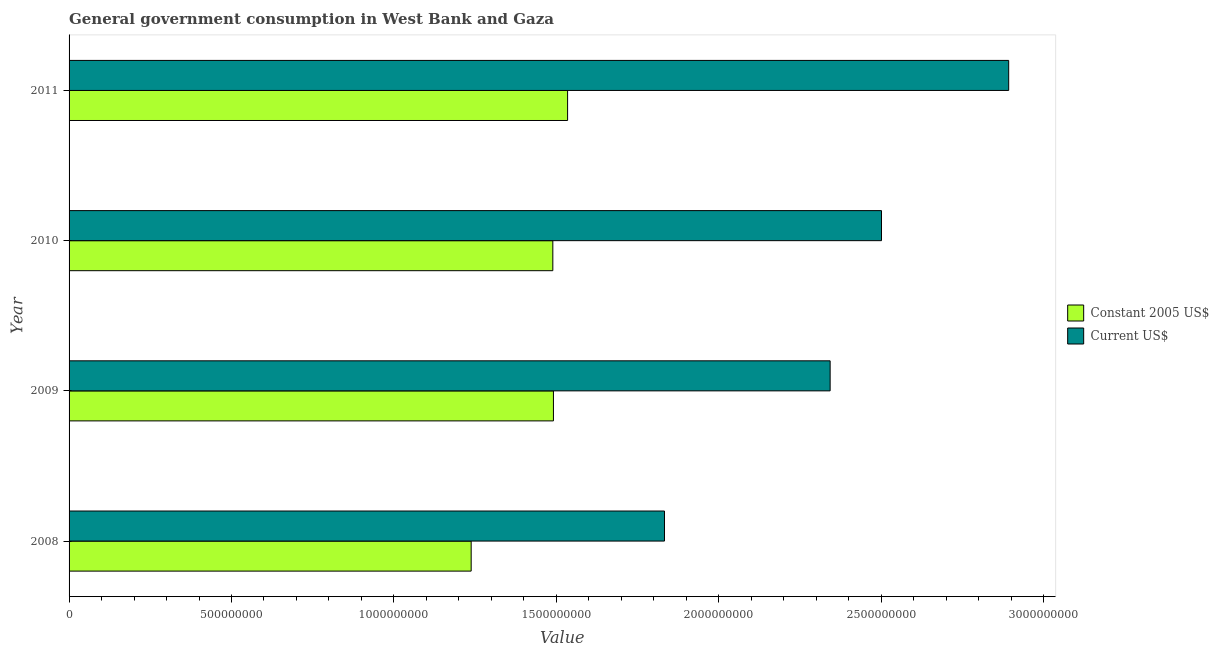How many different coloured bars are there?
Make the answer very short. 2. Are the number of bars per tick equal to the number of legend labels?
Provide a short and direct response. Yes. How many bars are there on the 2nd tick from the top?
Your answer should be compact. 2. How many bars are there on the 4th tick from the bottom?
Provide a short and direct response. 2. What is the label of the 2nd group of bars from the top?
Ensure brevity in your answer.  2010. In how many cases, is the number of bars for a given year not equal to the number of legend labels?
Provide a succinct answer. 0. What is the value consumed in constant 2005 us$ in 2009?
Ensure brevity in your answer.  1.49e+09. Across all years, what is the maximum value consumed in current us$?
Provide a short and direct response. 2.89e+09. Across all years, what is the minimum value consumed in constant 2005 us$?
Provide a succinct answer. 1.24e+09. In which year was the value consumed in constant 2005 us$ maximum?
Give a very brief answer. 2011. In which year was the value consumed in current us$ minimum?
Provide a short and direct response. 2008. What is the total value consumed in constant 2005 us$ in the graph?
Ensure brevity in your answer.  5.75e+09. What is the difference between the value consumed in constant 2005 us$ in 2009 and that in 2011?
Offer a terse response. -4.36e+07. What is the difference between the value consumed in current us$ in 2011 and the value consumed in constant 2005 us$ in 2010?
Your response must be concise. 1.40e+09. What is the average value consumed in current us$ per year?
Ensure brevity in your answer.  2.39e+09. In the year 2008, what is the difference between the value consumed in constant 2005 us$ and value consumed in current us$?
Offer a very short reply. -5.95e+08. In how many years, is the value consumed in constant 2005 us$ greater than 400000000 ?
Offer a terse response. 4. What is the ratio of the value consumed in current us$ in 2009 to that in 2010?
Provide a succinct answer. 0.94. Is the difference between the value consumed in constant 2005 us$ in 2010 and 2011 greater than the difference between the value consumed in current us$ in 2010 and 2011?
Ensure brevity in your answer.  Yes. What is the difference between the highest and the second highest value consumed in current us$?
Your response must be concise. 3.92e+08. What is the difference between the highest and the lowest value consumed in current us$?
Keep it short and to the point. 1.06e+09. In how many years, is the value consumed in constant 2005 us$ greater than the average value consumed in constant 2005 us$ taken over all years?
Give a very brief answer. 3. Is the sum of the value consumed in constant 2005 us$ in 2010 and 2011 greater than the maximum value consumed in current us$ across all years?
Give a very brief answer. Yes. What does the 1st bar from the top in 2009 represents?
Your answer should be compact. Current US$. What does the 2nd bar from the bottom in 2011 represents?
Give a very brief answer. Current US$. How many bars are there?
Your answer should be compact. 8. Are all the bars in the graph horizontal?
Your response must be concise. Yes. What is the difference between two consecutive major ticks on the X-axis?
Ensure brevity in your answer.  5.00e+08. Does the graph contain grids?
Provide a short and direct response. No. How are the legend labels stacked?
Your answer should be compact. Vertical. What is the title of the graph?
Offer a terse response. General government consumption in West Bank and Gaza. Does "Males" appear as one of the legend labels in the graph?
Give a very brief answer. No. What is the label or title of the X-axis?
Offer a terse response. Value. What is the label or title of the Y-axis?
Give a very brief answer. Year. What is the Value in Constant 2005 US$ in 2008?
Provide a short and direct response. 1.24e+09. What is the Value in Current US$ in 2008?
Keep it short and to the point. 1.83e+09. What is the Value of Constant 2005 US$ in 2009?
Give a very brief answer. 1.49e+09. What is the Value of Current US$ in 2009?
Make the answer very short. 2.34e+09. What is the Value in Constant 2005 US$ in 2010?
Give a very brief answer. 1.49e+09. What is the Value of Current US$ in 2010?
Offer a very short reply. 2.50e+09. What is the Value of Constant 2005 US$ in 2011?
Offer a terse response. 1.53e+09. What is the Value in Current US$ in 2011?
Offer a terse response. 2.89e+09. Across all years, what is the maximum Value in Constant 2005 US$?
Give a very brief answer. 1.53e+09. Across all years, what is the maximum Value of Current US$?
Provide a short and direct response. 2.89e+09. Across all years, what is the minimum Value of Constant 2005 US$?
Provide a succinct answer. 1.24e+09. Across all years, what is the minimum Value in Current US$?
Your response must be concise. 1.83e+09. What is the total Value in Constant 2005 US$ in the graph?
Your answer should be compact. 5.75e+09. What is the total Value of Current US$ in the graph?
Your answer should be very brief. 9.57e+09. What is the difference between the Value in Constant 2005 US$ in 2008 and that in 2009?
Provide a short and direct response. -2.53e+08. What is the difference between the Value in Current US$ in 2008 and that in 2009?
Provide a succinct answer. -5.10e+08. What is the difference between the Value of Constant 2005 US$ in 2008 and that in 2010?
Your answer should be very brief. -2.51e+08. What is the difference between the Value of Current US$ in 2008 and that in 2010?
Provide a short and direct response. -6.68e+08. What is the difference between the Value in Constant 2005 US$ in 2008 and that in 2011?
Ensure brevity in your answer.  -2.97e+08. What is the difference between the Value of Current US$ in 2008 and that in 2011?
Your answer should be very brief. -1.06e+09. What is the difference between the Value of Constant 2005 US$ in 2009 and that in 2010?
Offer a terse response. 1.92e+06. What is the difference between the Value of Current US$ in 2009 and that in 2010?
Make the answer very short. -1.58e+08. What is the difference between the Value in Constant 2005 US$ in 2009 and that in 2011?
Your answer should be compact. -4.36e+07. What is the difference between the Value of Current US$ in 2009 and that in 2011?
Your answer should be compact. -5.50e+08. What is the difference between the Value of Constant 2005 US$ in 2010 and that in 2011?
Offer a very short reply. -4.55e+07. What is the difference between the Value of Current US$ in 2010 and that in 2011?
Provide a short and direct response. -3.92e+08. What is the difference between the Value of Constant 2005 US$ in 2008 and the Value of Current US$ in 2009?
Provide a short and direct response. -1.10e+09. What is the difference between the Value in Constant 2005 US$ in 2008 and the Value in Current US$ in 2010?
Provide a succinct answer. -1.26e+09. What is the difference between the Value in Constant 2005 US$ in 2008 and the Value in Current US$ in 2011?
Provide a succinct answer. -1.65e+09. What is the difference between the Value of Constant 2005 US$ in 2009 and the Value of Current US$ in 2010?
Your answer should be very brief. -1.01e+09. What is the difference between the Value in Constant 2005 US$ in 2009 and the Value in Current US$ in 2011?
Make the answer very short. -1.40e+09. What is the difference between the Value in Constant 2005 US$ in 2010 and the Value in Current US$ in 2011?
Your answer should be compact. -1.40e+09. What is the average Value in Constant 2005 US$ per year?
Provide a succinct answer. 1.44e+09. What is the average Value of Current US$ per year?
Your answer should be very brief. 2.39e+09. In the year 2008, what is the difference between the Value in Constant 2005 US$ and Value in Current US$?
Your response must be concise. -5.95e+08. In the year 2009, what is the difference between the Value in Constant 2005 US$ and Value in Current US$?
Your answer should be compact. -8.52e+08. In the year 2010, what is the difference between the Value in Constant 2005 US$ and Value in Current US$?
Offer a very short reply. -1.01e+09. In the year 2011, what is the difference between the Value of Constant 2005 US$ and Value of Current US$?
Your response must be concise. -1.36e+09. What is the ratio of the Value of Constant 2005 US$ in 2008 to that in 2009?
Your response must be concise. 0.83. What is the ratio of the Value in Current US$ in 2008 to that in 2009?
Offer a very short reply. 0.78. What is the ratio of the Value of Constant 2005 US$ in 2008 to that in 2010?
Provide a short and direct response. 0.83. What is the ratio of the Value of Current US$ in 2008 to that in 2010?
Your answer should be compact. 0.73. What is the ratio of the Value of Constant 2005 US$ in 2008 to that in 2011?
Ensure brevity in your answer.  0.81. What is the ratio of the Value in Current US$ in 2008 to that in 2011?
Your answer should be compact. 0.63. What is the ratio of the Value of Current US$ in 2009 to that in 2010?
Ensure brevity in your answer.  0.94. What is the ratio of the Value of Constant 2005 US$ in 2009 to that in 2011?
Keep it short and to the point. 0.97. What is the ratio of the Value in Current US$ in 2009 to that in 2011?
Your answer should be compact. 0.81. What is the ratio of the Value in Constant 2005 US$ in 2010 to that in 2011?
Ensure brevity in your answer.  0.97. What is the ratio of the Value in Current US$ in 2010 to that in 2011?
Offer a very short reply. 0.86. What is the difference between the highest and the second highest Value in Constant 2005 US$?
Keep it short and to the point. 4.36e+07. What is the difference between the highest and the second highest Value in Current US$?
Your response must be concise. 3.92e+08. What is the difference between the highest and the lowest Value in Constant 2005 US$?
Provide a short and direct response. 2.97e+08. What is the difference between the highest and the lowest Value of Current US$?
Provide a succinct answer. 1.06e+09. 